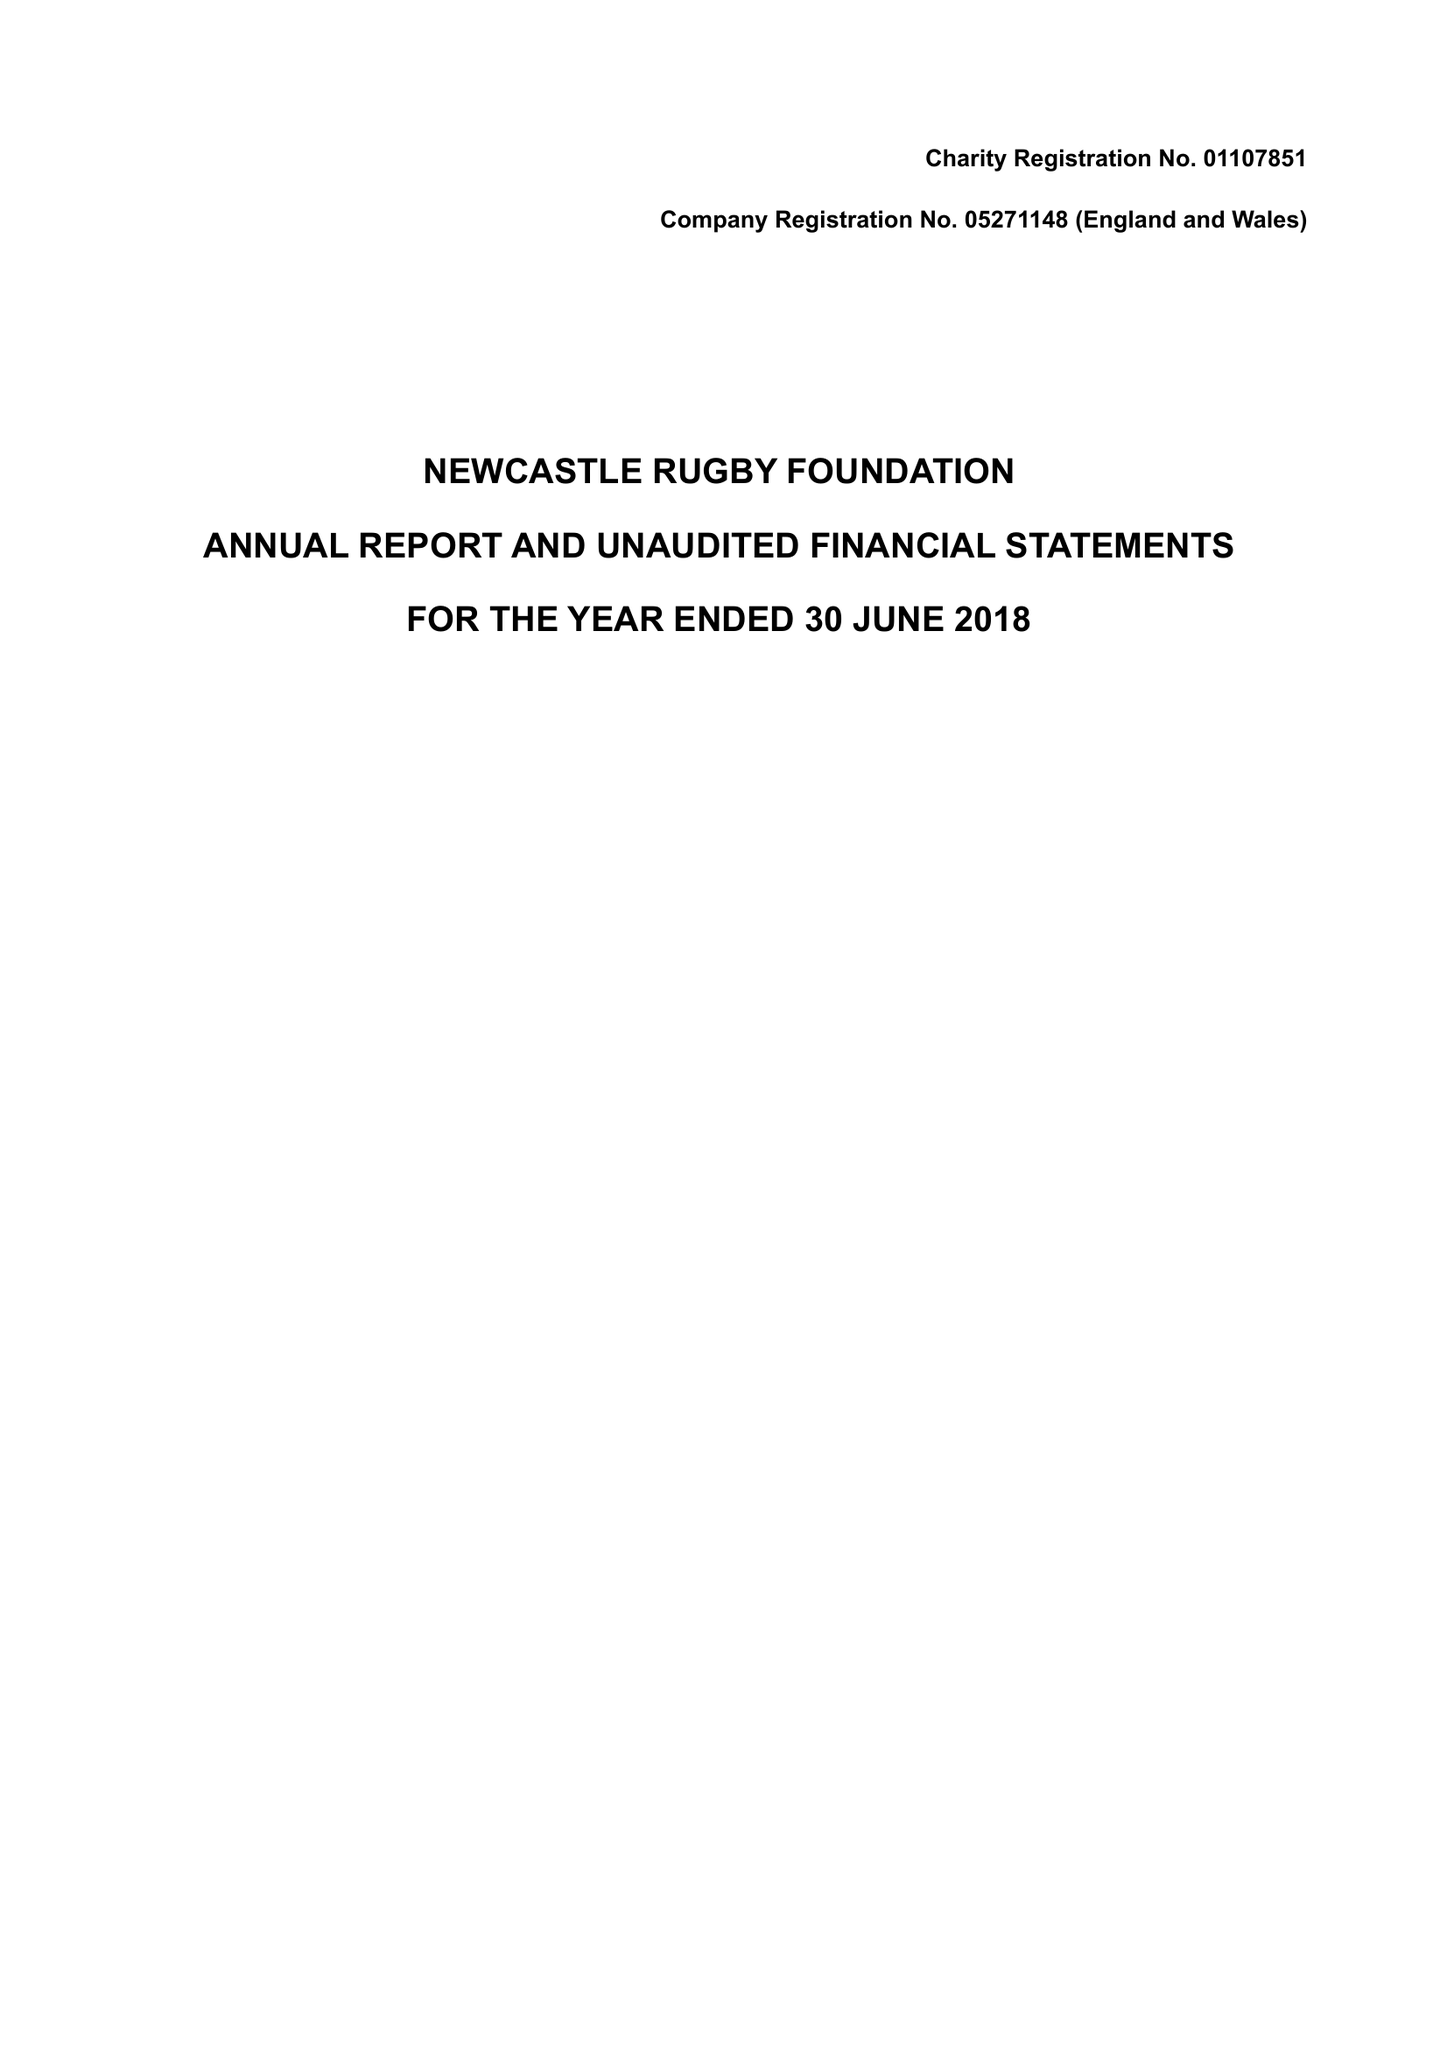What is the value for the address__postcode?
Answer the question using a single word or phrase. NE13 8AF 